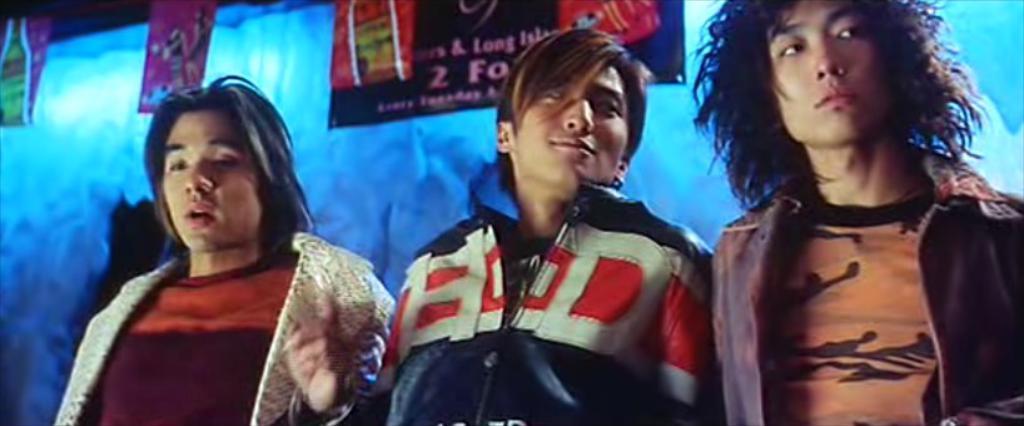Could you give a brief overview of what you see in this image? In this image we can see three people standing and smiling. In the background there are boards. 